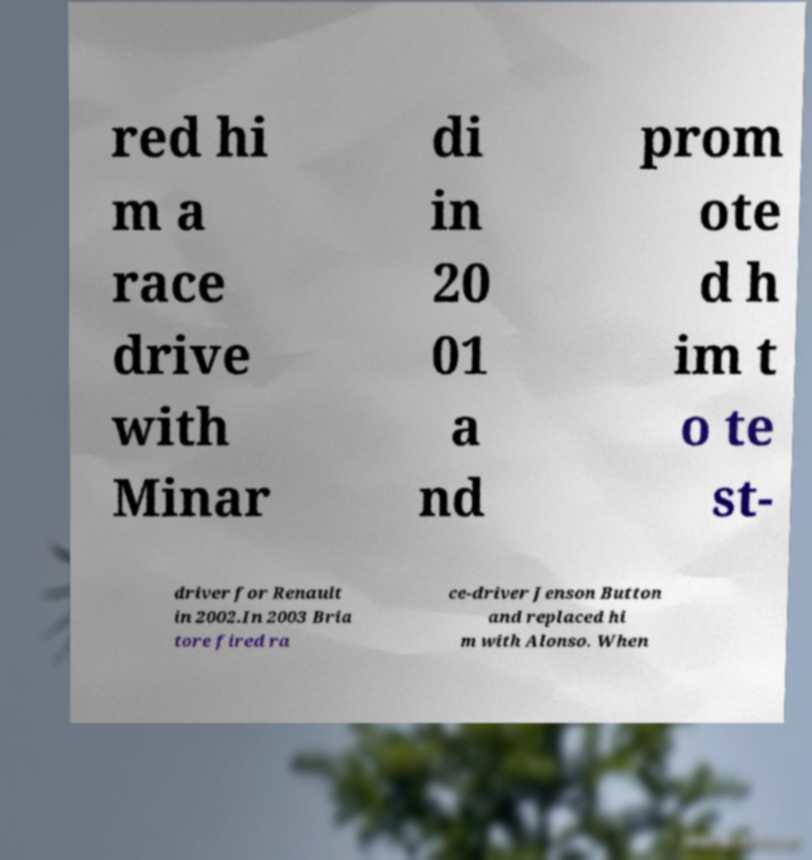I need the written content from this picture converted into text. Can you do that? red hi m a race drive with Minar di in 20 01 a nd prom ote d h im t o te st- driver for Renault in 2002.In 2003 Bria tore fired ra ce-driver Jenson Button and replaced hi m with Alonso. When 